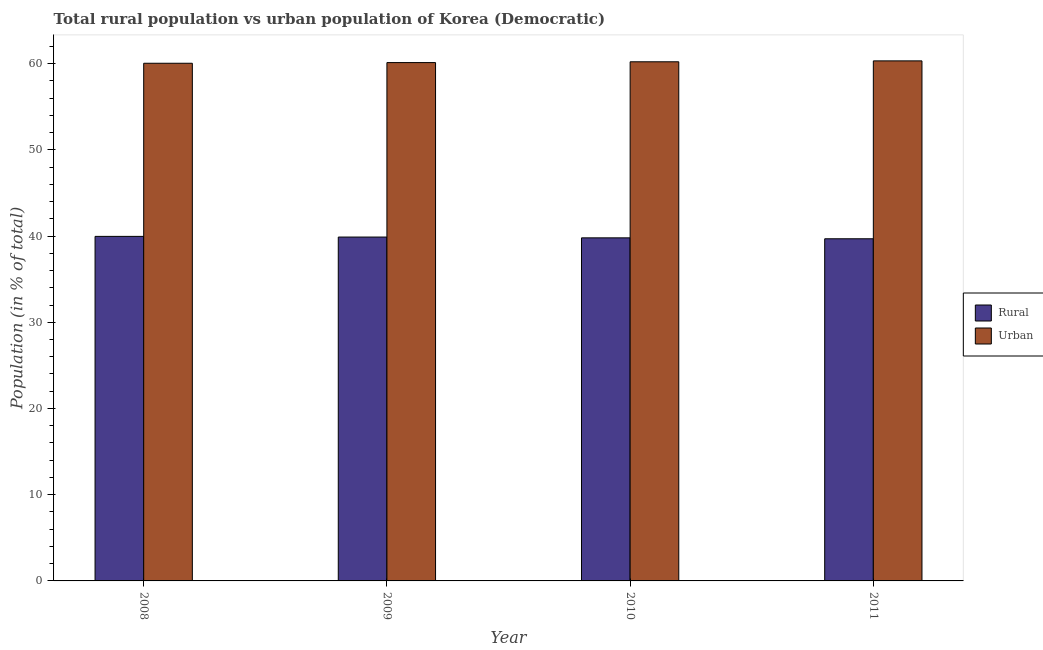How many bars are there on the 2nd tick from the left?
Keep it short and to the point. 2. How many bars are there on the 4th tick from the right?
Make the answer very short. 2. In how many cases, is the number of bars for a given year not equal to the number of legend labels?
Your response must be concise. 0. What is the rural population in 2008?
Your answer should be compact. 39.96. Across all years, what is the maximum rural population?
Provide a short and direct response. 39.96. Across all years, what is the minimum rural population?
Your answer should be very brief. 39.68. In which year was the rural population maximum?
Give a very brief answer. 2008. What is the total urban population in the graph?
Your answer should be compact. 240.68. What is the difference between the rural population in 2008 and that in 2011?
Make the answer very short. 0.28. What is the difference between the urban population in 2011 and the rural population in 2008?
Provide a succinct answer. 0.28. What is the average urban population per year?
Offer a very short reply. 60.17. What is the ratio of the rural population in 2010 to that in 2011?
Your answer should be compact. 1. Is the difference between the urban population in 2008 and 2011 greater than the difference between the rural population in 2008 and 2011?
Offer a very short reply. No. What is the difference between the highest and the second highest rural population?
Your answer should be compact. 0.08. What is the difference between the highest and the lowest rural population?
Your answer should be compact. 0.28. In how many years, is the rural population greater than the average rural population taken over all years?
Provide a succinct answer. 2. What does the 1st bar from the left in 2009 represents?
Make the answer very short. Rural. What does the 1st bar from the right in 2010 represents?
Keep it short and to the point. Urban. How many bars are there?
Your response must be concise. 8. Are all the bars in the graph horizontal?
Provide a succinct answer. No. How many years are there in the graph?
Provide a succinct answer. 4. What is the difference between two consecutive major ticks on the Y-axis?
Ensure brevity in your answer.  10. Does the graph contain any zero values?
Offer a very short reply. No. What is the title of the graph?
Offer a terse response. Total rural population vs urban population of Korea (Democratic). What is the label or title of the X-axis?
Your answer should be compact. Year. What is the label or title of the Y-axis?
Ensure brevity in your answer.  Population (in % of total). What is the Population (in % of total) of Rural in 2008?
Provide a succinct answer. 39.96. What is the Population (in % of total) of Urban in 2008?
Keep it short and to the point. 60.04. What is the Population (in % of total) in Rural in 2009?
Give a very brief answer. 39.88. What is the Population (in % of total) in Urban in 2009?
Ensure brevity in your answer.  60.12. What is the Population (in % of total) in Rural in 2010?
Provide a short and direct response. 39.79. What is the Population (in % of total) of Urban in 2010?
Keep it short and to the point. 60.21. What is the Population (in % of total) in Rural in 2011?
Provide a succinct answer. 39.68. What is the Population (in % of total) in Urban in 2011?
Make the answer very short. 60.32. Across all years, what is the maximum Population (in % of total) in Rural?
Offer a terse response. 39.96. Across all years, what is the maximum Population (in % of total) in Urban?
Make the answer very short. 60.32. Across all years, what is the minimum Population (in % of total) in Rural?
Offer a terse response. 39.68. Across all years, what is the minimum Population (in % of total) in Urban?
Provide a short and direct response. 60.04. What is the total Population (in % of total) of Rural in the graph?
Make the answer very short. 159.32. What is the total Population (in % of total) of Urban in the graph?
Give a very brief answer. 240.68. What is the difference between the Population (in % of total) of Rural in 2008 and that in 2009?
Make the answer very short. 0.08. What is the difference between the Population (in % of total) in Urban in 2008 and that in 2009?
Ensure brevity in your answer.  -0.08. What is the difference between the Population (in % of total) of Rural in 2008 and that in 2010?
Provide a succinct answer. 0.17. What is the difference between the Population (in % of total) in Urban in 2008 and that in 2010?
Offer a terse response. -0.17. What is the difference between the Population (in % of total) in Rural in 2008 and that in 2011?
Make the answer very short. 0.28. What is the difference between the Population (in % of total) in Urban in 2008 and that in 2011?
Offer a very short reply. -0.28. What is the difference between the Population (in % of total) of Rural in 2009 and that in 2010?
Your response must be concise. 0.09. What is the difference between the Population (in % of total) in Urban in 2009 and that in 2010?
Provide a succinct answer. -0.09. What is the difference between the Population (in % of total) in Rural in 2009 and that in 2011?
Make the answer very short. 0.2. What is the difference between the Population (in % of total) in Urban in 2009 and that in 2011?
Your response must be concise. -0.2. What is the difference between the Population (in % of total) in Rural in 2010 and that in 2011?
Offer a terse response. 0.11. What is the difference between the Population (in % of total) in Urban in 2010 and that in 2011?
Ensure brevity in your answer.  -0.11. What is the difference between the Population (in % of total) of Rural in 2008 and the Population (in % of total) of Urban in 2009?
Your answer should be very brief. -20.16. What is the difference between the Population (in % of total) of Rural in 2008 and the Population (in % of total) of Urban in 2010?
Offer a terse response. -20.25. What is the difference between the Population (in % of total) of Rural in 2008 and the Population (in % of total) of Urban in 2011?
Your answer should be compact. -20.36. What is the difference between the Population (in % of total) in Rural in 2009 and the Population (in % of total) in Urban in 2010?
Your answer should be very brief. -20.33. What is the difference between the Population (in % of total) in Rural in 2009 and the Population (in % of total) in Urban in 2011?
Your answer should be compact. -20.43. What is the difference between the Population (in % of total) of Rural in 2010 and the Population (in % of total) of Urban in 2011?
Make the answer very short. -20.53. What is the average Population (in % of total) in Rural per year?
Your response must be concise. 39.83. What is the average Population (in % of total) of Urban per year?
Offer a terse response. 60.17. In the year 2008, what is the difference between the Population (in % of total) in Rural and Population (in % of total) in Urban?
Make the answer very short. -20.08. In the year 2009, what is the difference between the Population (in % of total) in Rural and Population (in % of total) in Urban?
Give a very brief answer. -20.24. In the year 2010, what is the difference between the Population (in % of total) of Rural and Population (in % of total) of Urban?
Give a very brief answer. -20.42. In the year 2011, what is the difference between the Population (in % of total) of Rural and Population (in % of total) of Urban?
Make the answer very short. -20.63. What is the ratio of the Population (in % of total) in Rural in 2008 to that in 2009?
Ensure brevity in your answer.  1. What is the ratio of the Population (in % of total) of Urban in 2008 to that in 2009?
Your response must be concise. 1. What is the ratio of the Population (in % of total) of Rural in 2008 to that in 2010?
Give a very brief answer. 1. What is the ratio of the Population (in % of total) in Urban in 2008 to that in 2010?
Make the answer very short. 1. What is the ratio of the Population (in % of total) in Rural in 2009 to that in 2010?
Keep it short and to the point. 1. What is the ratio of the Population (in % of total) in Urban in 2009 to that in 2010?
Offer a very short reply. 1. What is the ratio of the Population (in % of total) of Rural in 2009 to that in 2011?
Your answer should be very brief. 1. What is the difference between the highest and the second highest Population (in % of total) of Rural?
Offer a very short reply. 0.08. What is the difference between the highest and the second highest Population (in % of total) of Urban?
Your answer should be very brief. 0.11. What is the difference between the highest and the lowest Population (in % of total) in Rural?
Offer a very short reply. 0.28. What is the difference between the highest and the lowest Population (in % of total) in Urban?
Make the answer very short. 0.28. 